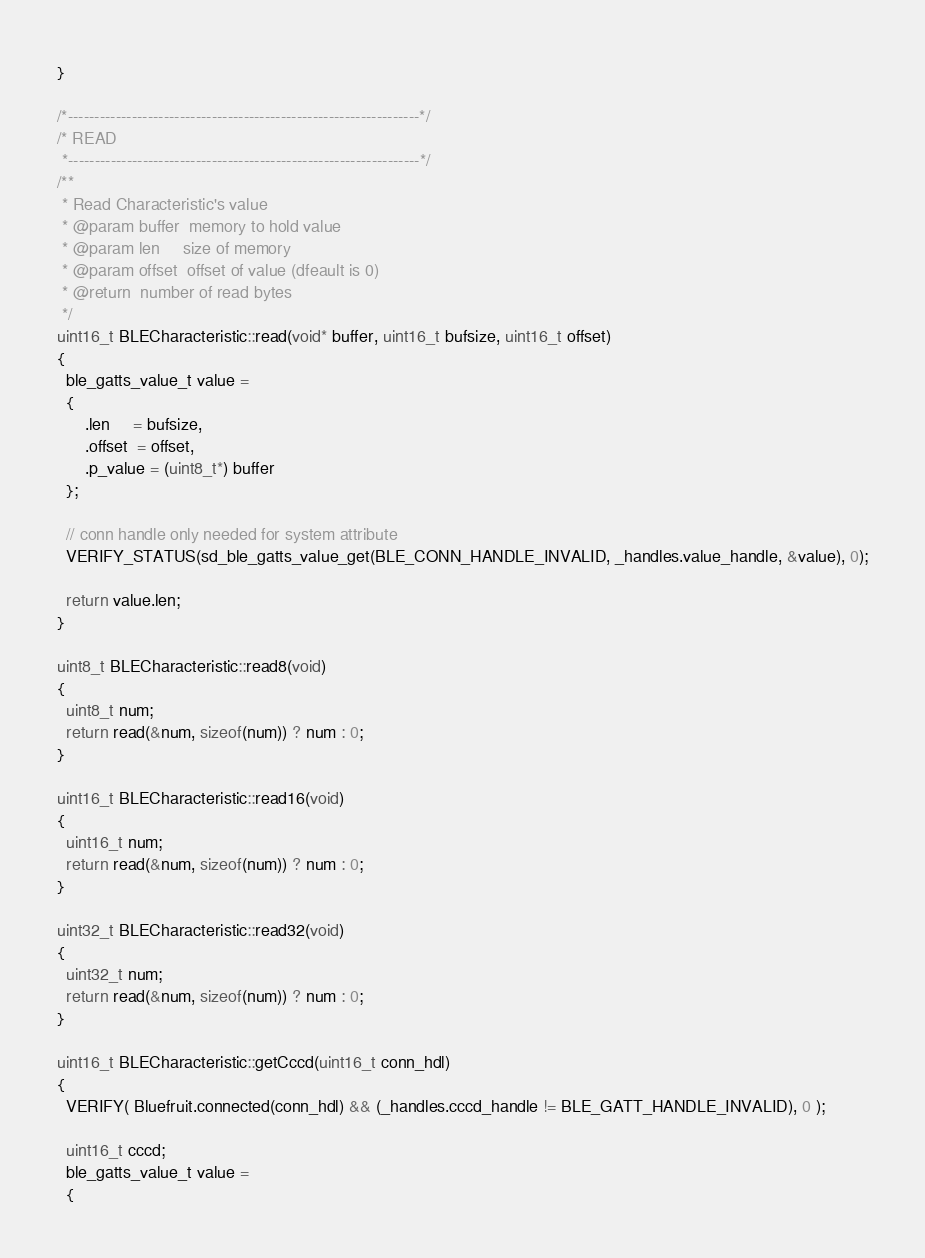Convert code to text. <code><loc_0><loc_0><loc_500><loc_500><_C++_>}

/*------------------------------------------------------------------*/
/* READ
 *------------------------------------------------------------------*/
/**
 * Read Characteristic's value
 * @param buffer  memory to hold value
 * @param len     size of memory
 * @param offset  offset of value (dfeault is 0)
 * @return  number of read bytes
 */
uint16_t BLECharacteristic::read(void* buffer, uint16_t bufsize, uint16_t offset)
{
  ble_gatts_value_t value =
  {
      .len     = bufsize,
      .offset  = offset,
      .p_value = (uint8_t*) buffer
  };

  // conn handle only needed for system attribute
  VERIFY_STATUS(sd_ble_gatts_value_get(BLE_CONN_HANDLE_INVALID, _handles.value_handle, &value), 0);

  return value.len;
}

uint8_t BLECharacteristic::read8(void)
{
  uint8_t num;
  return read(&num, sizeof(num)) ? num : 0;
}

uint16_t BLECharacteristic::read16(void)
{
  uint16_t num;
  return read(&num, sizeof(num)) ? num : 0;
}

uint32_t BLECharacteristic::read32(void)
{
  uint32_t num;
  return read(&num, sizeof(num)) ? num : 0;
}

uint16_t BLECharacteristic::getCccd(uint16_t conn_hdl)
{
  VERIFY( Bluefruit.connected(conn_hdl) && (_handles.cccd_handle != BLE_GATT_HANDLE_INVALID), 0 );

  uint16_t cccd;
  ble_gatts_value_t value =
  {</code> 